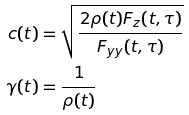<formula> <loc_0><loc_0><loc_500><loc_500>c ( t ) & = \sqrt { \frac { 2 \rho ( t ) F _ { z } ( t , \tau ) } { F _ { y y } ( t , \tau ) } } \\ \gamma ( t ) & = \frac { 1 } { \rho ( t ) }</formula> 